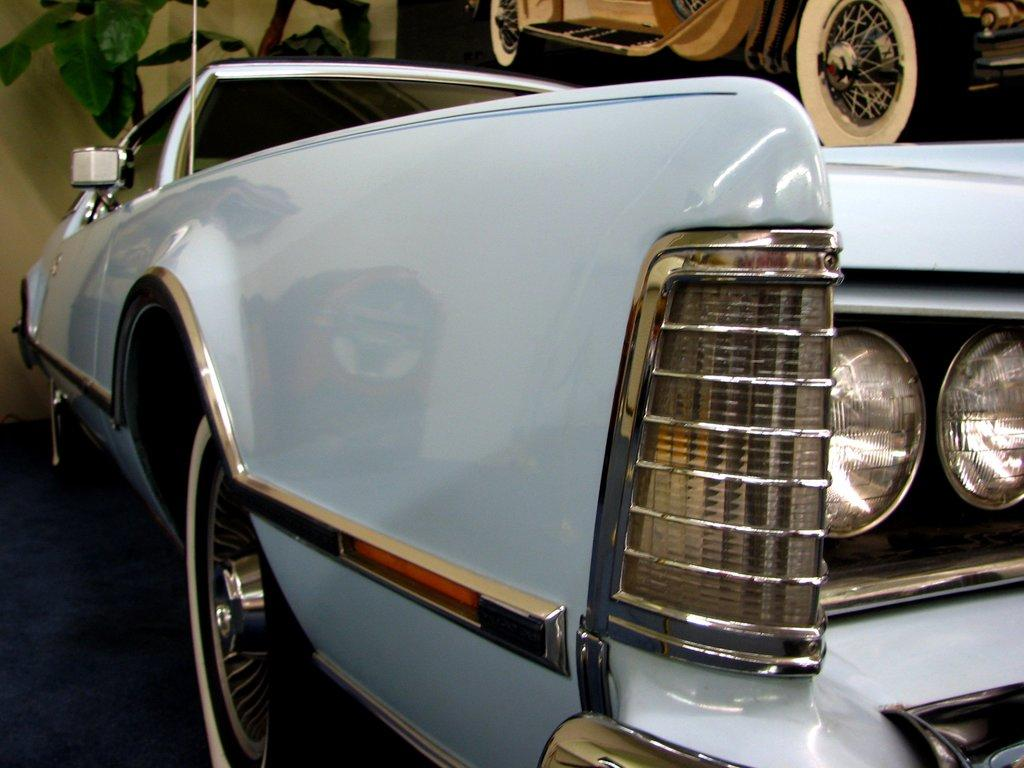What type of vehicle is depicted in the image? There is a white color vehicle in the image. How is the vehicle represented in the image? There is an image of a vehicle in the image. What other object can be seen in the image besides the vehicle? There is a plant in the image. How many icicles are hanging from the vehicle in the image? There are no icicles present in the image. In which direction is the vehicle moving in the image? The image does not show the vehicle in motion, so it is not possible to determine its direction. 